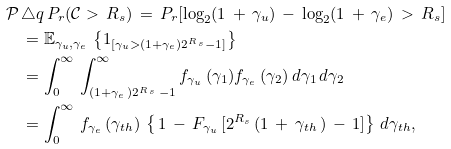Convert formula to latex. <formula><loc_0><loc_0><loc_500><loc_500>\mathcal { P } \, & \triangle q \, P _ { r } ( \mathcal { C } > \, R _ { s } ) \, = \, P _ { r } [ \log _ { 2 } ( 1 \, + \, \gamma _ { u } ) \, - \, \log _ { 2 } ( 1 \, + \, \gamma _ { e } ) \, > \, R _ { s } ] \\ & = \mathbb { E } _ { \gamma _ { u } , \gamma _ { e } } \, \left \{ 1 _ { [ \gamma _ { u } > ( 1 + \gamma _ { e } ) 2 ^ { R \, _ { s } } - 1 ] } \right \} \\ & = \int _ { 0 } ^ { \infty } \, \int _ { ( 1 + \gamma _ { e } \, ) 2 ^ { R \, _ { s } } \, - 1 } ^ { \infty } f _ { \gamma _ { u } } \, ( \gamma _ { 1 } ) f _ { \gamma _ { e } } \, ( \gamma _ { 2 } ) \, d \gamma _ { 1 } \, d \gamma _ { 2 } \\ & = \int _ { 0 } ^ { \infty } \, f _ { \gamma _ { e } } \, ( \gamma _ { t h } ) \, \left \{ \, 1 \, - \, F _ { \gamma _ { u } } \, [ 2 ^ { R _ { s } } \, ( 1 \, + \, \gamma _ { t h } \, ) \, - \, 1 ] \right \} \, d \gamma _ { t h } ,</formula> 